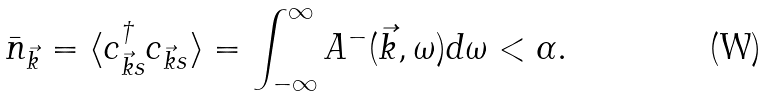<formula> <loc_0><loc_0><loc_500><loc_500>\bar { n } _ { \vec { k } } = \langle c ^ { \dagger } _ { \vec { k } s } c _ { \vec { k } s } \rangle = \int _ { - \infty } ^ { \infty } A ^ { - } ( \vec { k } , \omega ) d \omega < \alpha .</formula> 